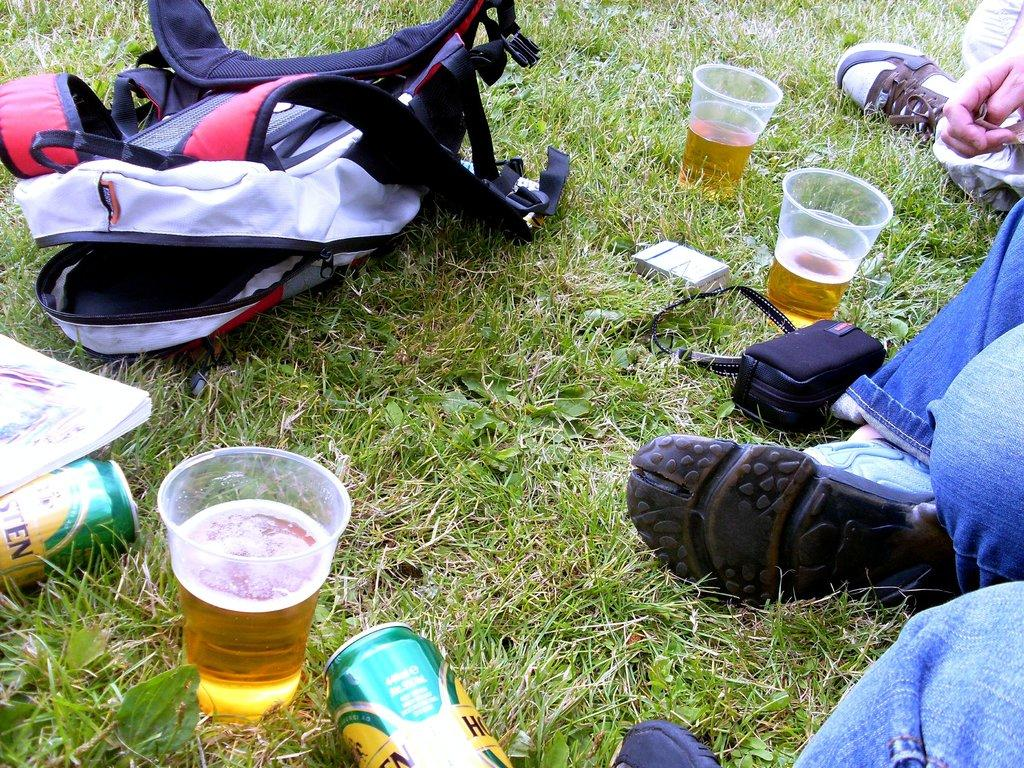What objects can be seen in the image? There are glasses, a bag, and a book on the ground in the image. What is the person in the image doing? The person is sitting in the image. What is the person wearing? The person is wearing blue pants. What type of surface is visible in the image? There is grass visible in the image. What is the color of the grass? The grass is green. What type of brass instrument is the person playing in the image? There is no brass instrument present in the image; the person is simply sitting. What amusement park can be seen in the background of the image? There is no amusement park visible in the image; it features a person sitting on grass. 